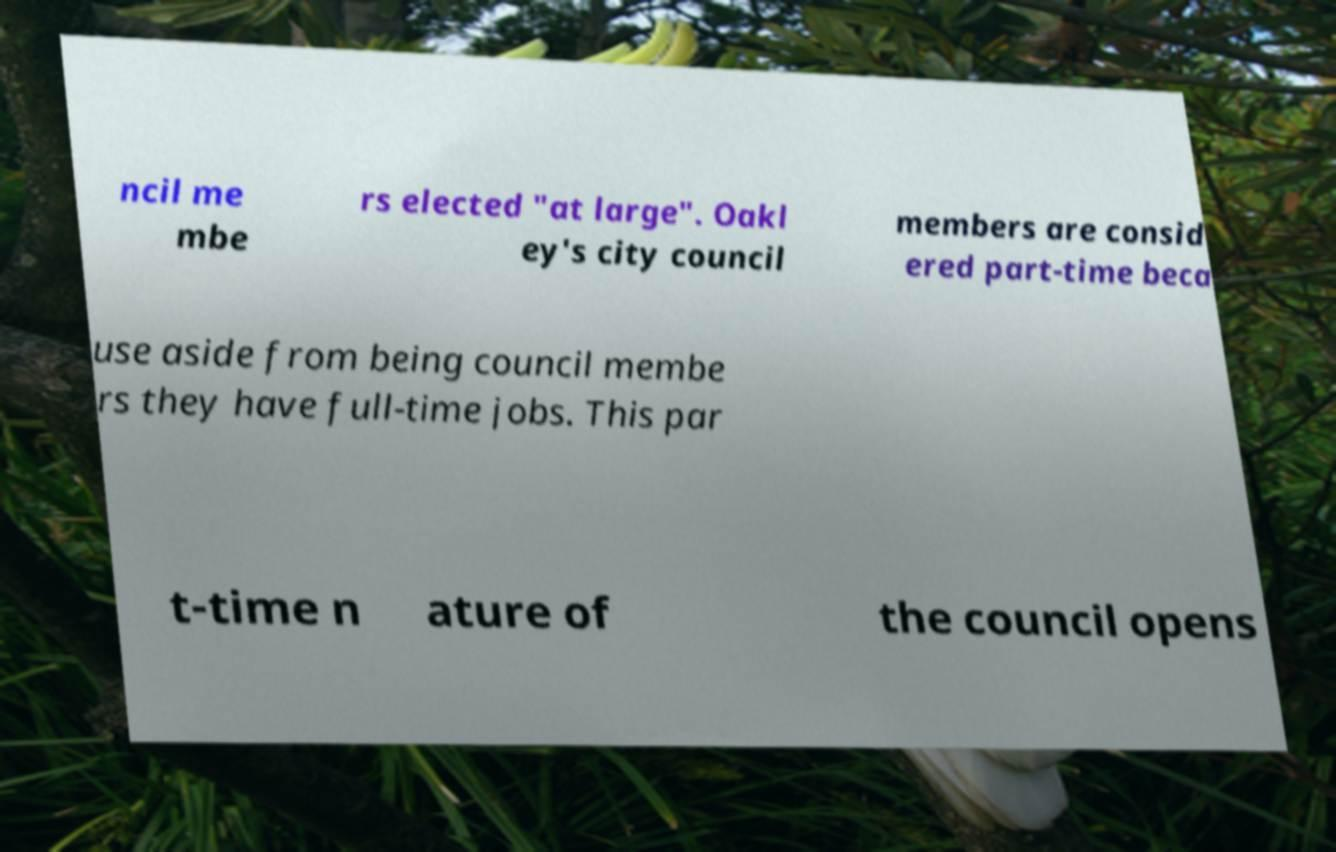Can you accurately transcribe the text from the provided image for me? ncil me mbe rs elected "at large". Oakl ey's city council members are consid ered part-time beca use aside from being council membe rs they have full-time jobs. This par t-time n ature of the council opens 